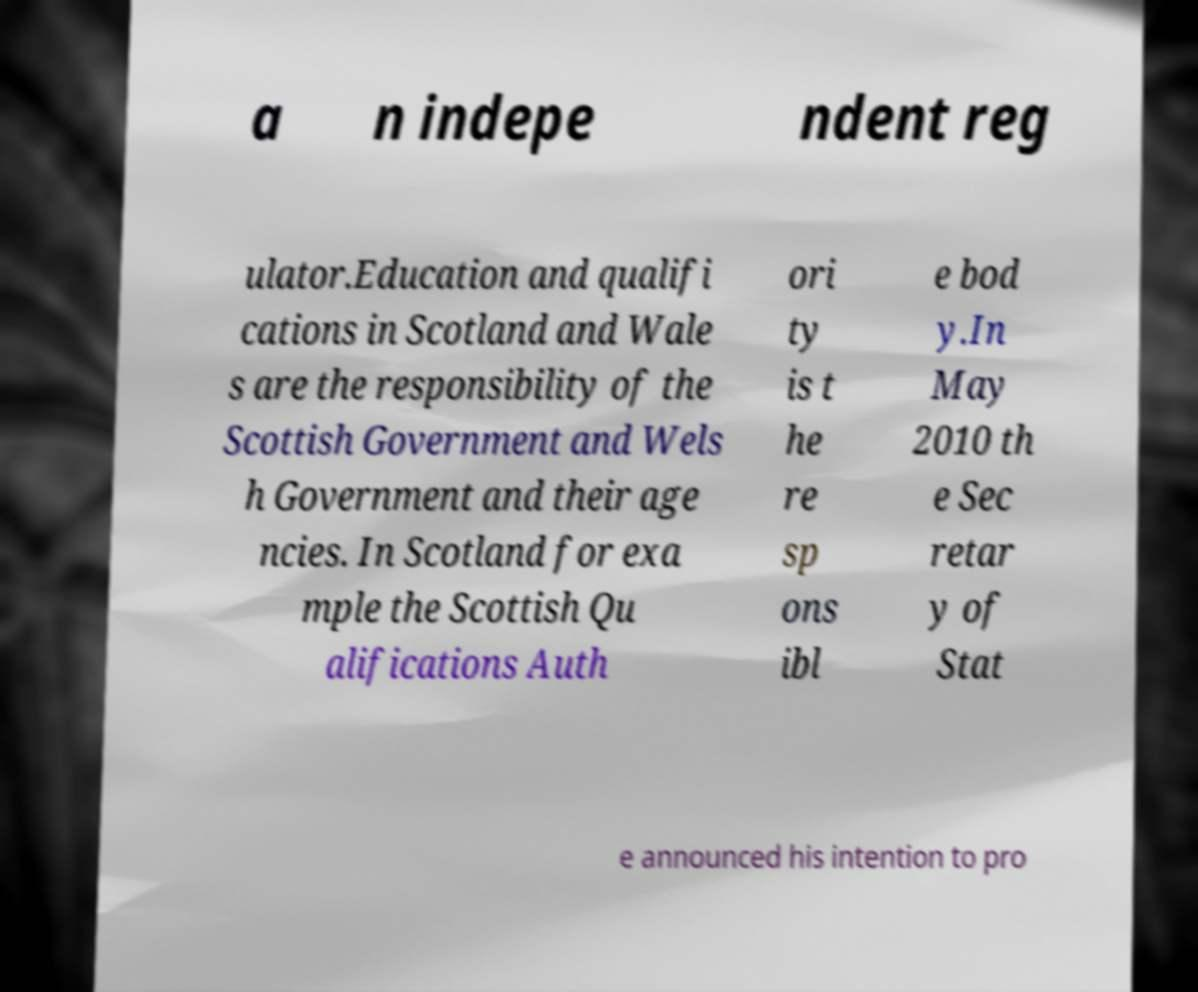Please identify and transcribe the text found in this image. a n indepe ndent reg ulator.Education and qualifi cations in Scotland and Wale s are the responsibility of the Scottish Government and Wels h Government and their age ncies. In Scotland for exa mple the Scottish Qu alifications Auth ori ty is t he re sp ons ibl e bod y.In May 2010 th e Sec retar y of Stat e announced his intention to pro 